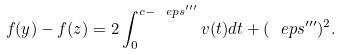Convert formula to latex. <formula><loc_0><loc_0><loc_500><loc_500>f ( y ) - f ( z ) = 2 \int _ { 0 } ^ { c - \ e p s ^ { \prime \prime \prime } } v ( t ) d t + ( \ e p s ^ { \prime \prime \prime } ) ^ { 2 } .</formula> 